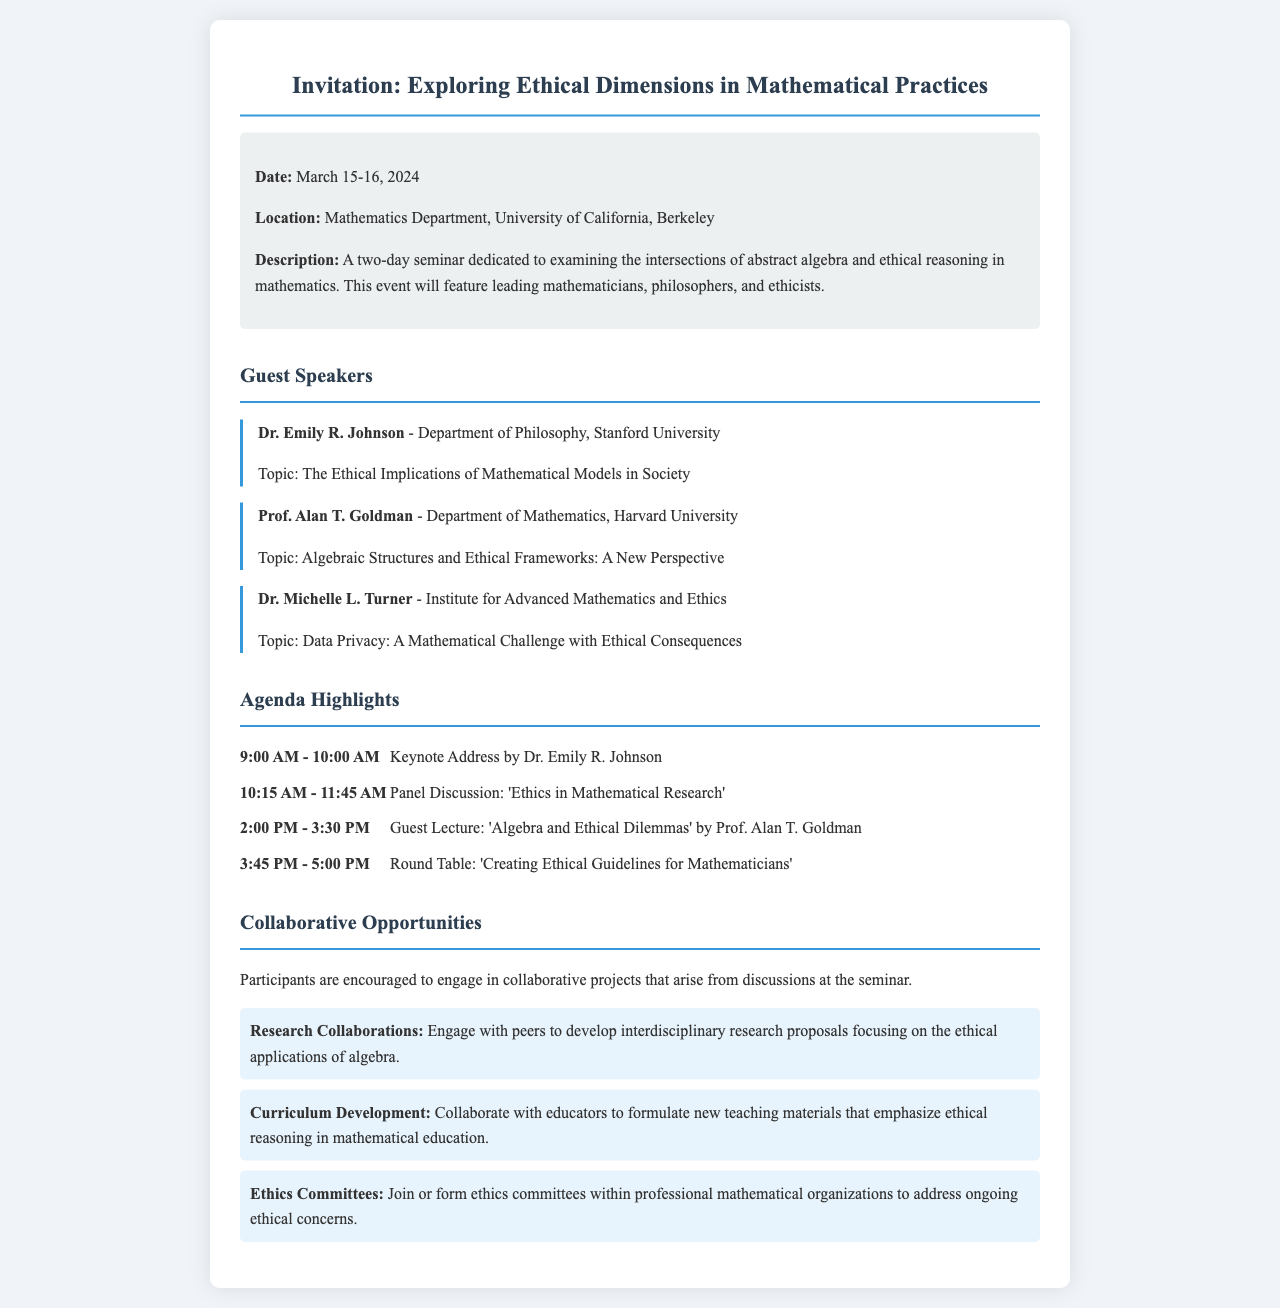What are the seminar dates? The seminar will be held on March 15-16, 2024, as stated in the document.
Answer: March 15-16, 2024 Who is the keynote speaker? The keynote address is given by Dr. Emily R. Johnson, according to the agenda highlights section.
Answer: Dr. Emily R. Johnson What is the location of the seminar? The location mentioned in the document is the Mathematics Department, University of California, Berkeley.
Answer: Mathematics Department, University of California, Berkeley What topic will Dr. Michelle L. Turner discuss? The topic is listed as "Data Privacy: A Mathematical Challenge with Ethical Consequences."
Answer: Data Privacy: A Mathematical Challenge with Ethical Consequences What is one collaborative opportunity mentioned? The document lists "Research Collaborations" as one of the opportunities for participants.
Answer: Research Collaborations How long is the panel discussion scheduled for? The panel discussion is scheduled from 10:15 AM to 11:45 AM, making it 1.5 hours long.
Answer: 1.5 hours Which speaker focuses on algebraic structures? Prof. Alan T. Goldman focuses on algebraic structures and ethical frameworks as noted in the guest speakers section.
Answer: Prof. Alan T. Goldman What will participants be encouraged to engage in? The document encourages participants to engage in collaborative projects.
Answer: Collaborative projects How many guest speakers are mentioned? Three guest speakers are introduced in the document.
Answer: Three 